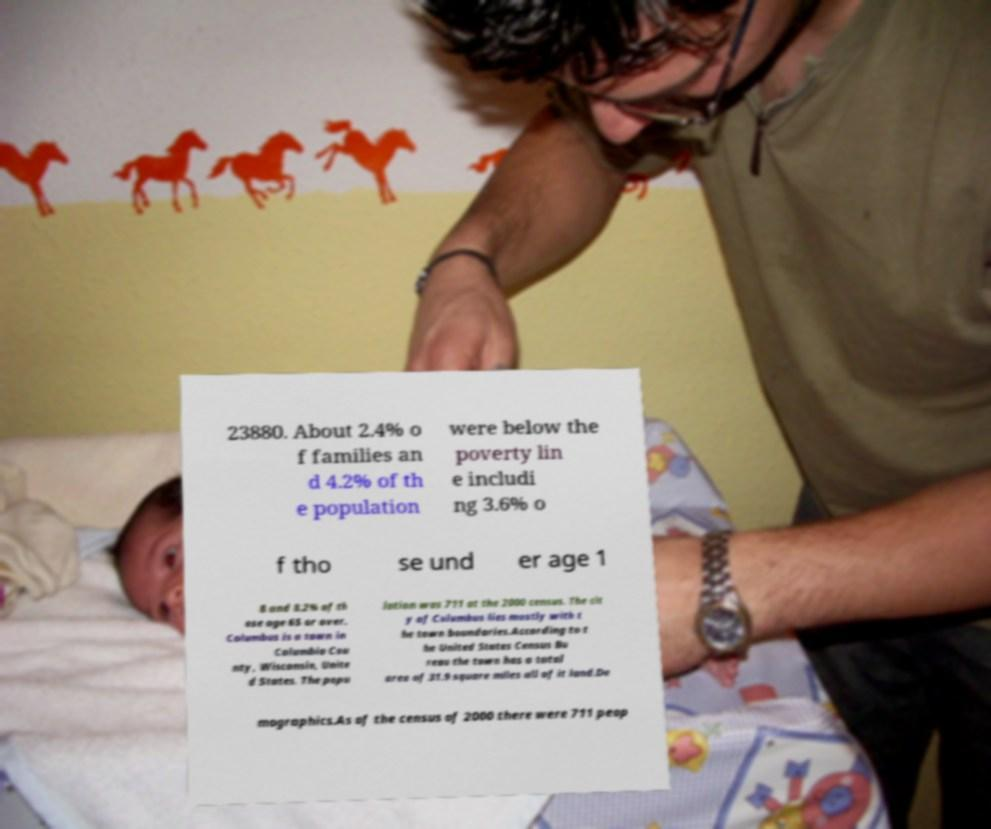Can you read and provide the text displayed in the image?This photo seems to have some interesting text. Can you extract and type it out for me? 23880. About 2.4% o f families an d 4.2% of th e population were below the poverty lin e includi ng 3.6% o f tho se und er age 1 8 and 8.2% of th ose age 65 or over. Columbus is a town in Columbia Cou nty, Wisconsin, Unite d States. The popu lation was 711 at the 2000 census. The cit y of Columbus lies mostly with t he town boundaries.According to t he United States Census Bu reau the town has a total area of 31.9 square miles all of it land.De mographics.As of the census of 2000 there were 711 peop 